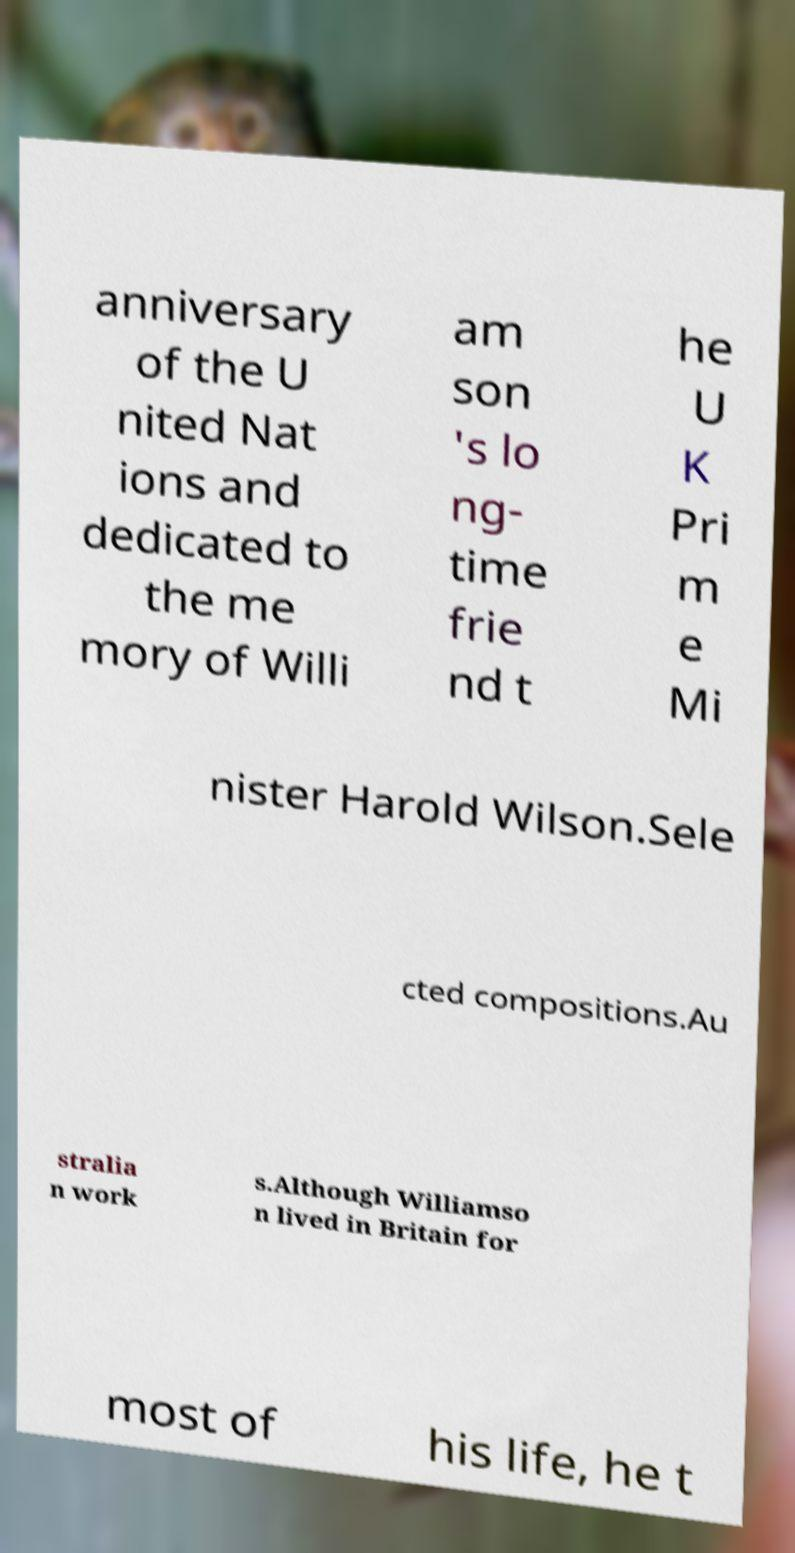I need the written content from this picture converted into text. Can you do that? anniversary of the U nited Nat ions and dedicated to the me mory of Willi am son 's lo ng- time frie nd t he U K Pri m e Mi nister Harold Wilson.Sele cted compositions.Au stralia n work s.Although Williamso n lived in Britain for most of his life, he t 